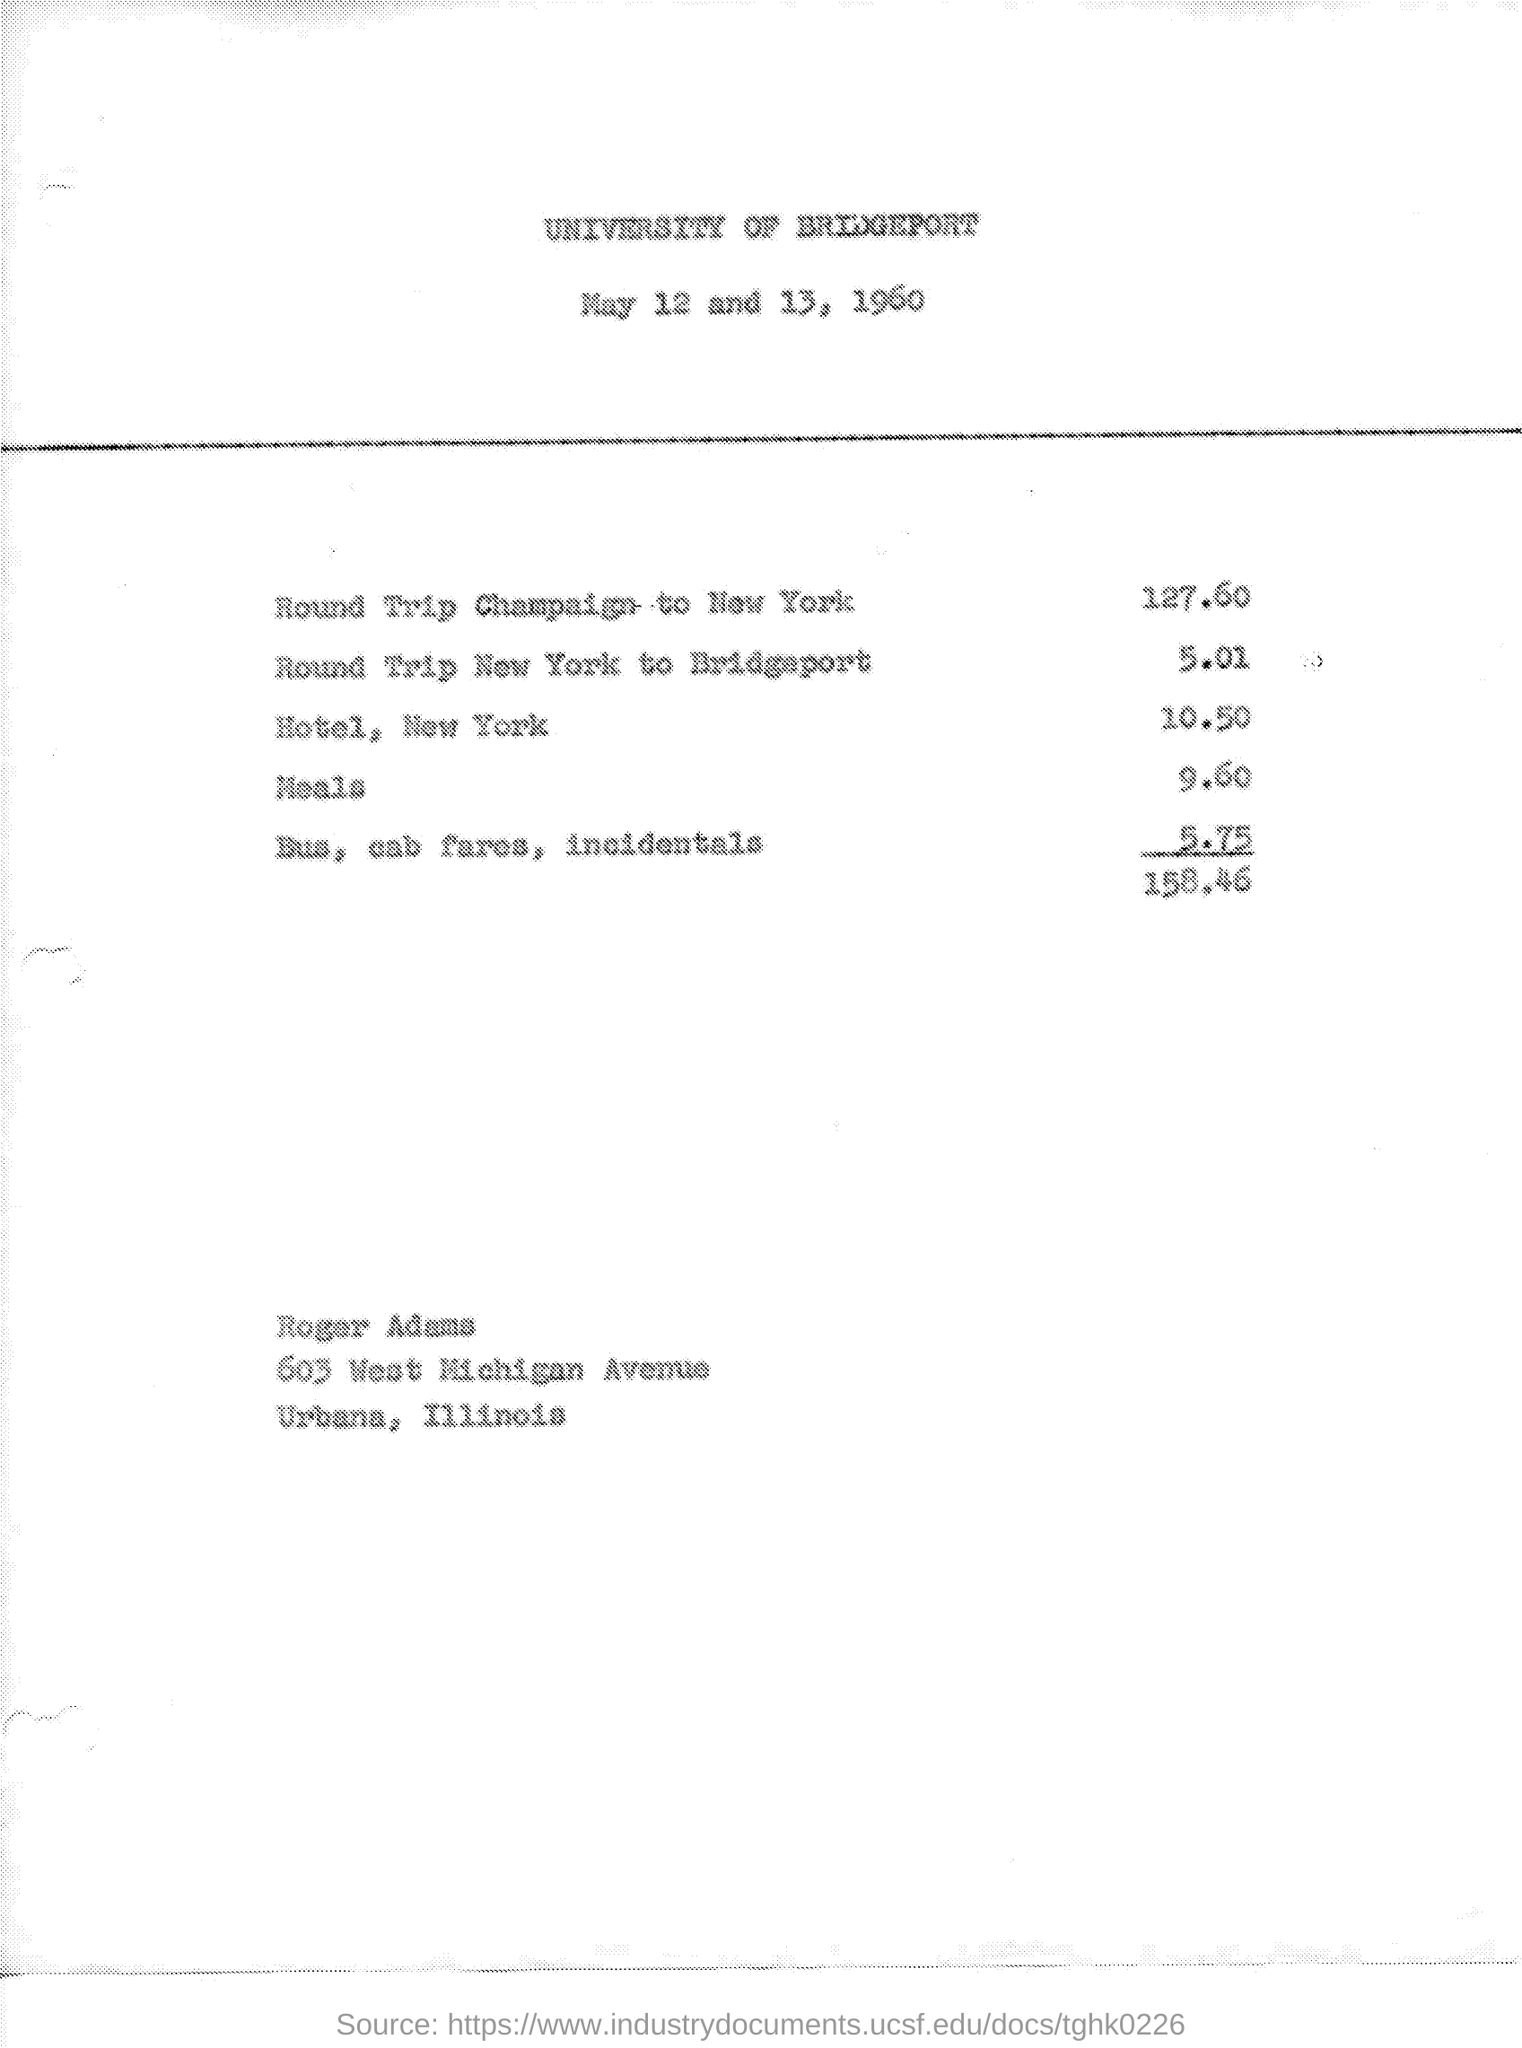Give some essential details in this illustration. The date on the document is May 12 and 13, 1960. The cost of meals is 9.60. The cost for a round trip journey from New York to Bridgeport is 5.01 dollars. The cost for a hotel in New York is 10.50. The cost for bus and cab fares, as well as incidentals, is 5.75. 